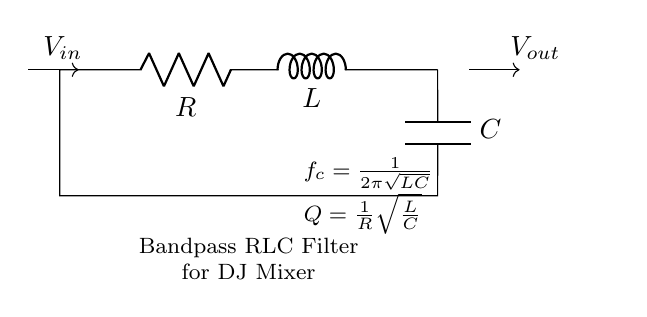What components are present in the circuit? The circuit includes a resistor, inductor, and capacitor, as clearly labeled on the diagram. Each component is represented by its respective symbol and identified with letters (R, L, and C).
Answer: Resistor, Inductor, Capacitor What is the function of this circuit? The circuit diagram indicates that it is a bandpass RLC filter, which is designed to allow specific frequency ranges to pass through while attenuating others. The label in the diagram directly states its purpose.
Answer: Bandpass filter What is the value of the cutoff frequency formula represented in the circuit? The cutoff frequency formula \(f_c = \frac{1}{2\pi\sqrt{LC}}\) is provided in the circuit diagram, indicating how the resonant frequency depends on the values of the inductor and capacitor.
Answer: One over two pi square root of LC What does the quality factor represent in this circuit? The quality factor \(Q\) defined as \(Q = \frac{1}{R}\sqrt{\frac{L}{C}}\) measures the selectivity or sharpness of the bandpass filter, which shows how effectively the circuit can isolate a specific frequency range relative to its bandwidth. This is also stated in the diagram.
Answer: Quality factor How can you determine whether the circuit is underdamped or overdamped? The damping type can be assessed by evaluating the values of \(R\), \(L\), and \(C\). If \(R\) is low relative to \(\sqrt{\frac{L}{C}}\), the circuit will be underdamped and exhibit oscillatory behavior. If \(R\) is high, it will be overdamped, leading to a slow return to equilibrium without oscillations. While this analysis isn't directly stated in the diagram, it follows from the characteristics of RLC circuits.
Answer: Damping analysis based on values What happens to the output voltage if the resistance is increased significantly? Increasing the resistance decreases the quality factor \(Q\), which means the selectivity of the filter is reduced. The output amplitude at the resonant frequency will be lower, as a high resistance causes more energy dissipation. This understanding connects the values given in the equation to the overall behavior of the circuit.
Answer: Lower output amplitude 